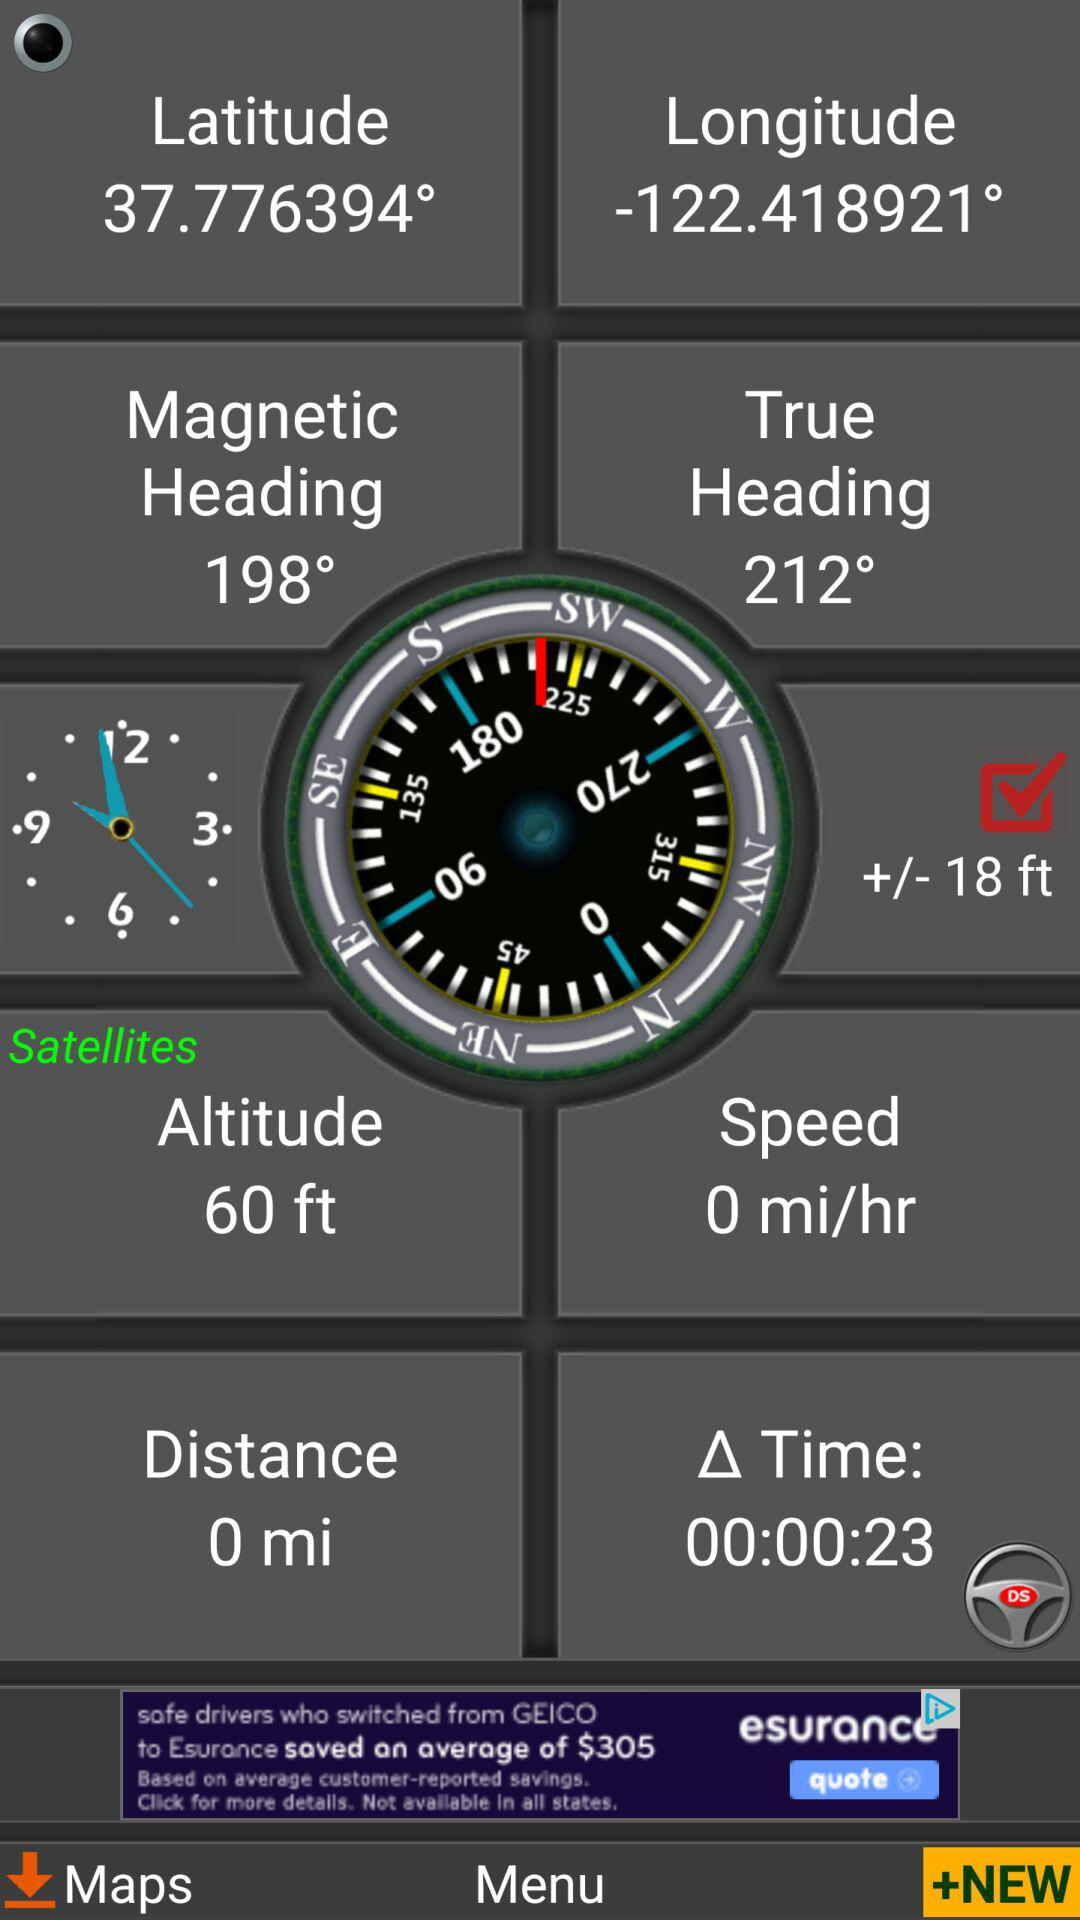What is the speed? The speed is 0 miles per hour. 